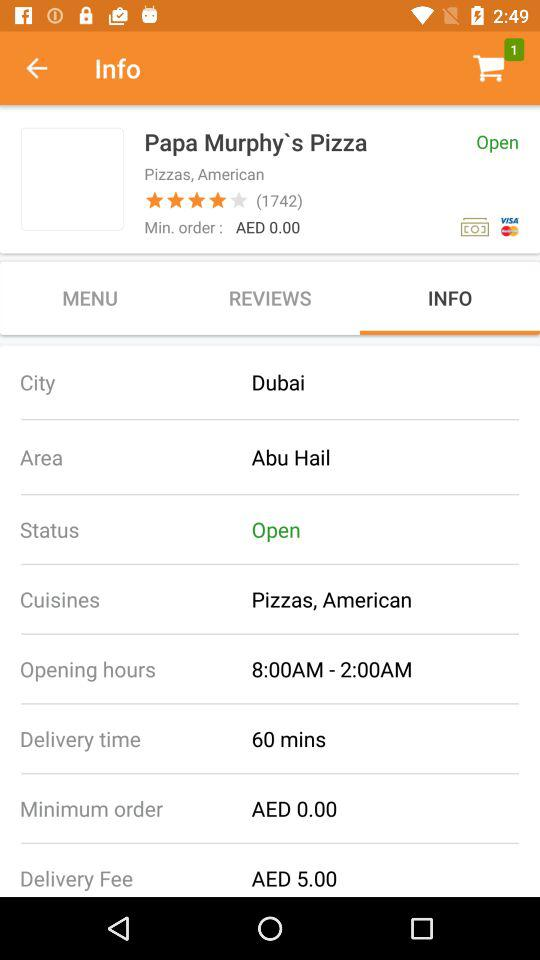How many views are there on the store?
When the provided information is insufficient, respond with <no answer>. <no answer> 